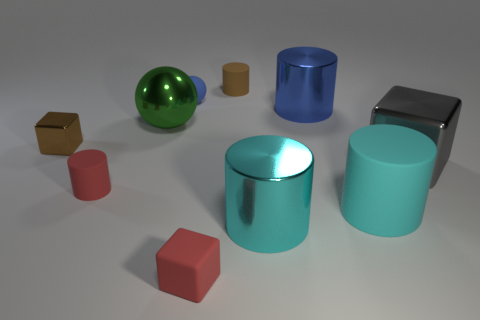Subtract all matte cubes. How many cubes are left? 2 Subtract all gray blocks. How many cyan cylinders are left? 2 Subtract 2 cylinders. How many cylinders are left? 3 Subtract all cyan cylinders. How many cylinders are left? 3 Subtract all green cubes. Subtract all purple balls. How many cubes are left? 3 Subtract all blocks. How many objects are left? 7 Subtract 0 green blocks. How many objects are left? 10 Subtract all small yellow matte cylinders. Subtract all cylinders. How many objects are left? 5 Add 6 small brown metallic objects. How many small brown metallic objects are left? 7 Add 1 red blocks. How many red blocks exist? 2 